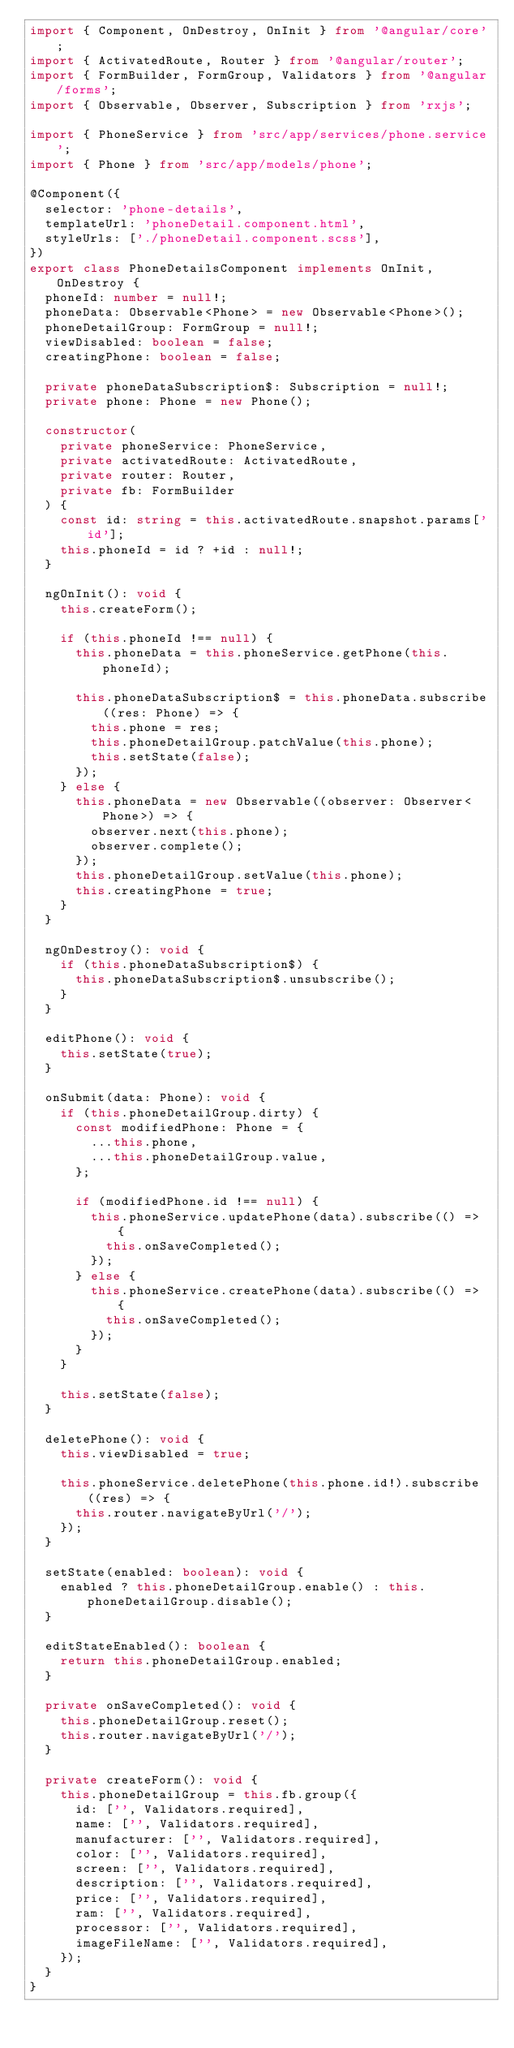Convert code to text. <code><loc_0><loc_0><loc_500><loc_500><_TypeScript_>import { Component, OnDestroy, OnInit } from '@angular/core';
import { ActivatedRoute, Router } from '@angular/router';
import { FormBuilder, FormGroup, Validators } from '@angular/forms';
import { Observable, Observer, Subscription } from 'rxjs';

import { PhoneService } from 'src/app/services/phone.service';
import { Phone } from 'src/app/models/phone';

@Component({
  selector: 'phone-details',
  templateUrl: 'phoneDetail.component.html',
  styleUrls: ['./phoneDetail.component.scss'],
})
export class PhoneDetailsComponent implements OnInit, OnDestroy {
  phoneId: number = null!;
  phoneData: Observable<Phone> = new Observable<Phone>();
  phoneDetailGroup: FormGroup = null!;
  viewDisabled: boolean = false;
  creatingPhone: boolean = false;

  private phoneDataSubscription$: Subscription = null!;
  private phone: Phone = new Phone();

  constructor(
    private phoneService: PhoneService,
    private activatedRoute: ActivatedRoute,
    private router: Router,
    private fb: FormBuilder
  ) {
    const id: string = this.activatedRoute.snapshot.params['id'];
    this.phoneId = id ? +id : null!;
  }

  ngOnInit(): void {
    this.createForm();

    if (this.phoneId !== null) {
      this.phoneData = this.phoneService.getPhone(this.phoneId);

      this.phoneDataSubscription$ = this.phoneData.subscribe((res: Phone) => {
        this.phone = res;
        this.phoneDetailGroup.patchValue(this.phone);
        this.setState(false);
      });
    } else {
      this.phoneData = new Observable((observer: Observer<Phone>) => {
        observer.next(this.phone);
        observer.complete();
      });
      this.phoneDetailGroup.setValue(this.phone);
      this.creatingPhone = true;
    }
  }

  ngOnDestroy(): void {
    if (this.phoneDataSubscription$) {
      this.phoneDataSubscription$.unsubscribe();
    }
  }

  editPhone(): void {
    this.setState(true);
  }

  onSubmit(data: Phone): void {
    if (this.phoneDetailGroup.dirty) {
      const modifiedPhone: Phone = {
        ...this.phone,
        ...this.phoneDetailGroup.value,
      };

      if (modifiedPhone.id !== null) {
        this.phoneService.updatePhone(data).subscribe(() => {
          this.onSaveCompleted();
        });
      } else {
        this.phoneService.createPhone(data).subscribe(() => {
          this.onSaveCompleted();
        });
      }
    }

    this.setState(false);
  }

  deletePhone(): void {
    this.viewDisabled = true;

    this.phoneService.deletePhone(this.phone.id!).subscribe((res) => {
      this.router.navigateByUrl('/');
    });
  }

  setState(enabled: boolean): void {
    enabled ? this.phoneDetailGroup.enable() : this.phoneDetailGroup.disable();
  }

  editStateEnabled(): boolean {
    return this.phoneDetailGroup.enabled;
  }

  private onSaveCompleted(): void {
    this.phoneDetailGroup.reset();
    this.router.navigateByUrl('/');
  }

  private createForm(): void {
    this.phoneDetailGroup = this.fb.group({
      id: ['', Validators.required],
      name: ['', Validators.required],
      manufacturer: ['', Validators.required],
      color: ['', Validators.required],
      screen: ['', Validators.required],
      description: ['', Validators.required],
      price: ['', Validators.required],
      ram: ['', Validators.required],
      processor: ['', Validators.required],
      imageFileName: ['', Validators.required],
    });
  }
}
</code> 